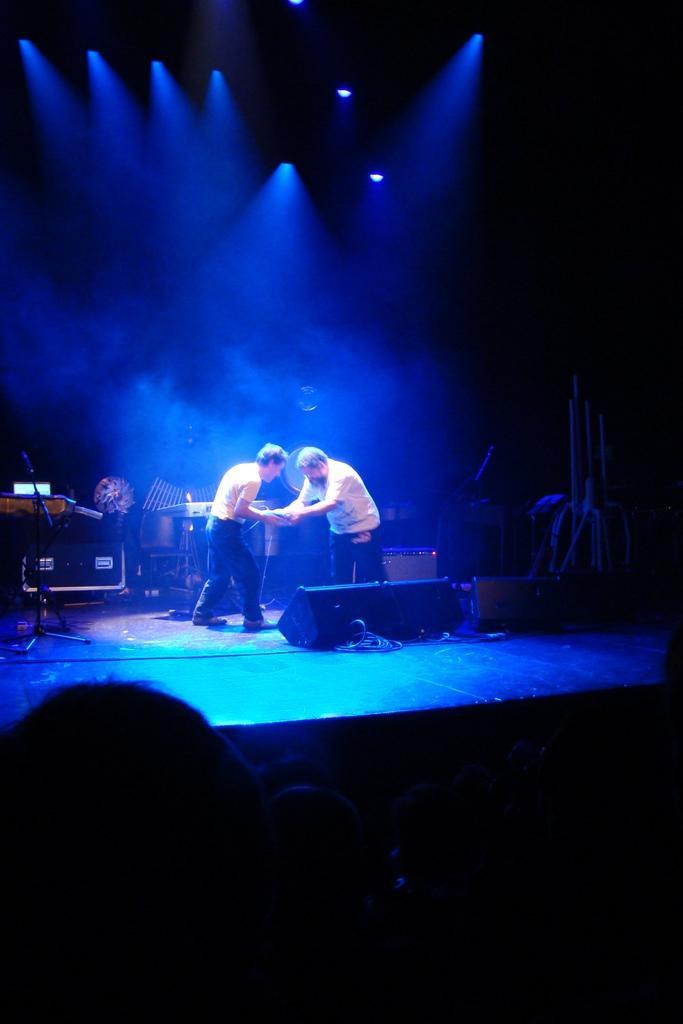Please provide a concise description of this image. In this image, we can see two people are standing on the stage. Here we can see few objects, stand, rods. At the bottom and background we can see a dark view. Top of the image, we can see few lights. 